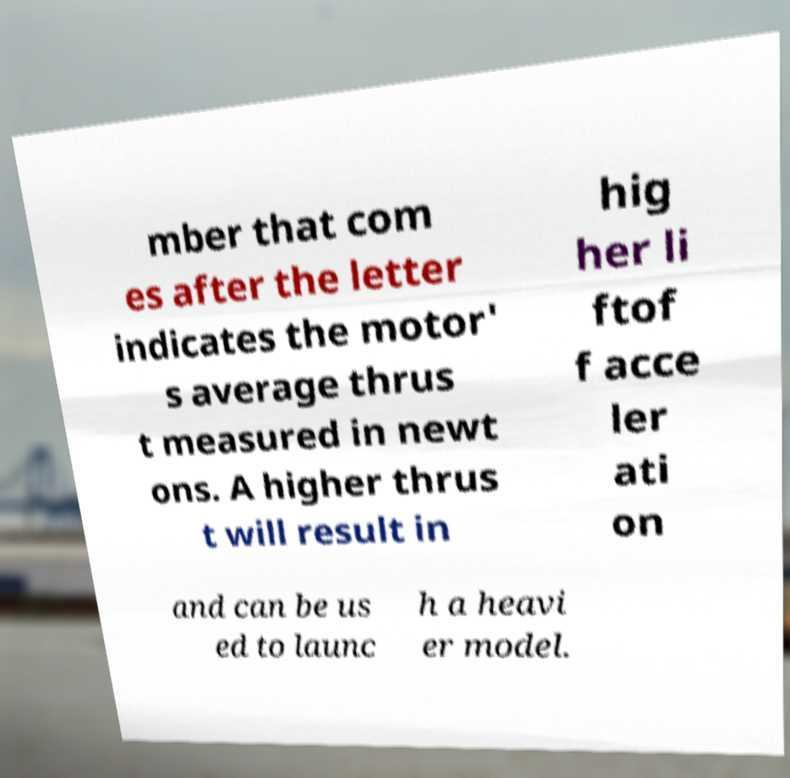Could you extract and type out the text from this image? mber that com es after the letter indicates the motor' s average thrus t measured in newt ons. A higher thrus t will result in hig her li ftof f acce ler ati on and can be us ed to launc h a heavi er model. 